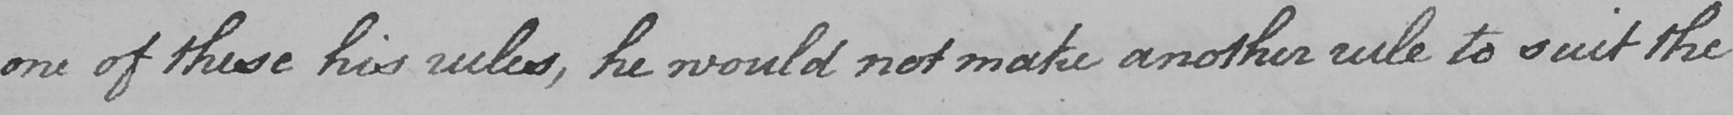What does this handwritten line say? one of these his rules , he would not make another rule to suit the 